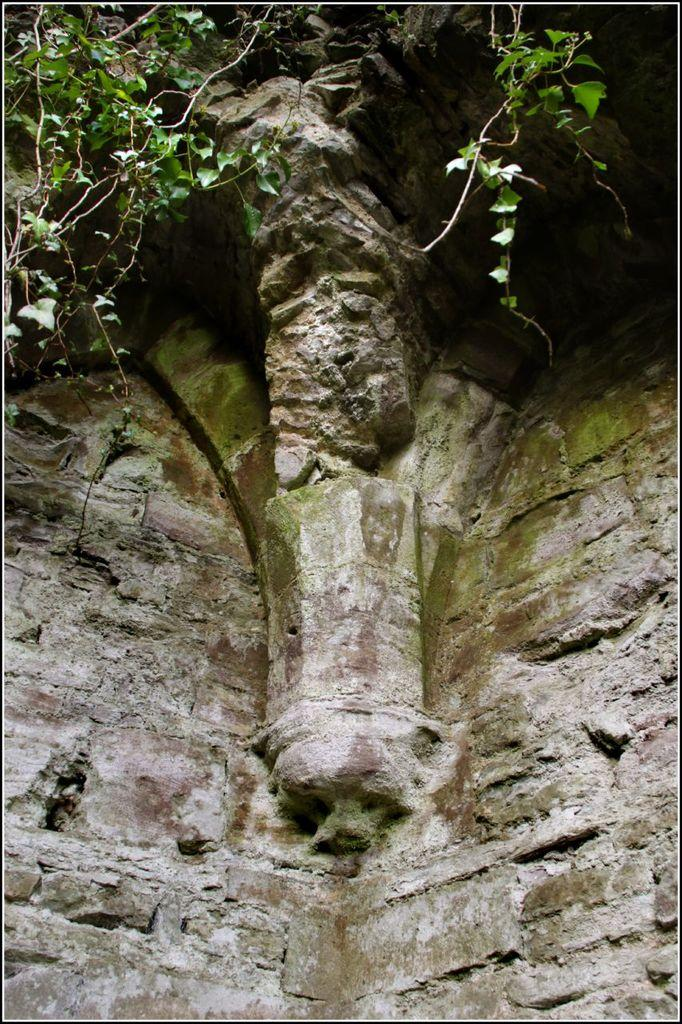What type of wall is shown in the image? There is a granite wall in the image. How close is the view of the granite wall in the image? The image provides a close view of the granite wall. What can be seen on top of the granite wall? There are green plant leaves visible on the top of the granite wall. Can you see a giraffe standing next to the granite wall in the image? No, there is no giraffe present in the image. What type of cast is visible on the granite wall in the image? There is no cast visible on the granite wall in the image. 